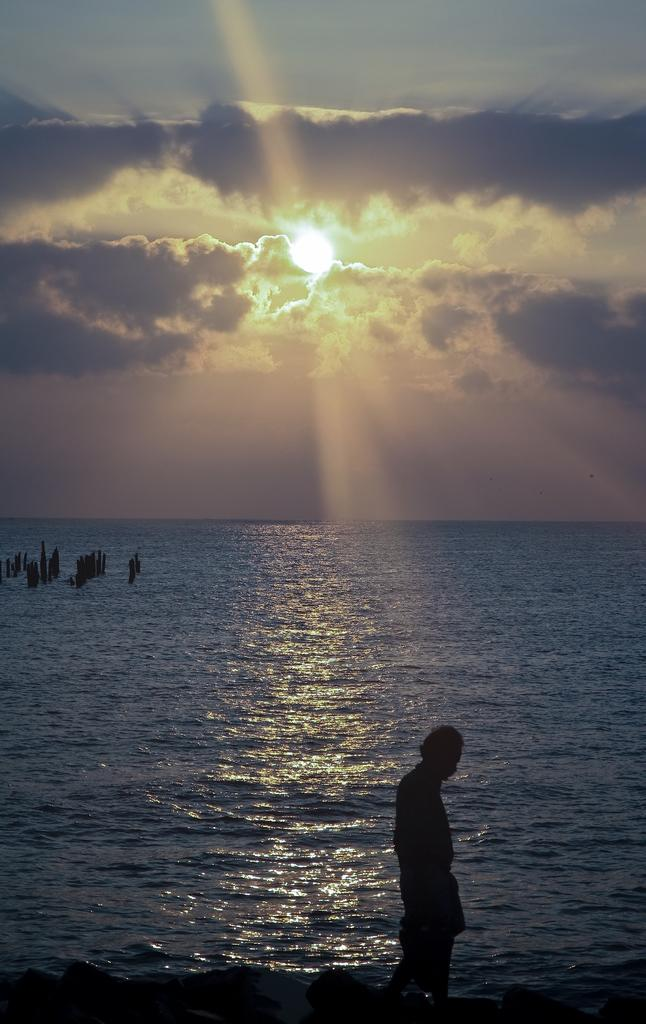What is the main subject of the image? There is a person standing in the image. Where is the person located in the image? The person is on the right side of the image. What can be seen in the background of the image? There is a water body in the background of the image. How would you describe the weather in the image? The sky is cloudy, but the sun is visible in the sky. What news is the person reading in the image? There is no news or any reading material visible in the image. How many sisters does the person have in the image? There is no information about the person's family or siblings in the image. Is the person playing baseball in the image? There is no baseball or any indication of the sport being played in the image. 